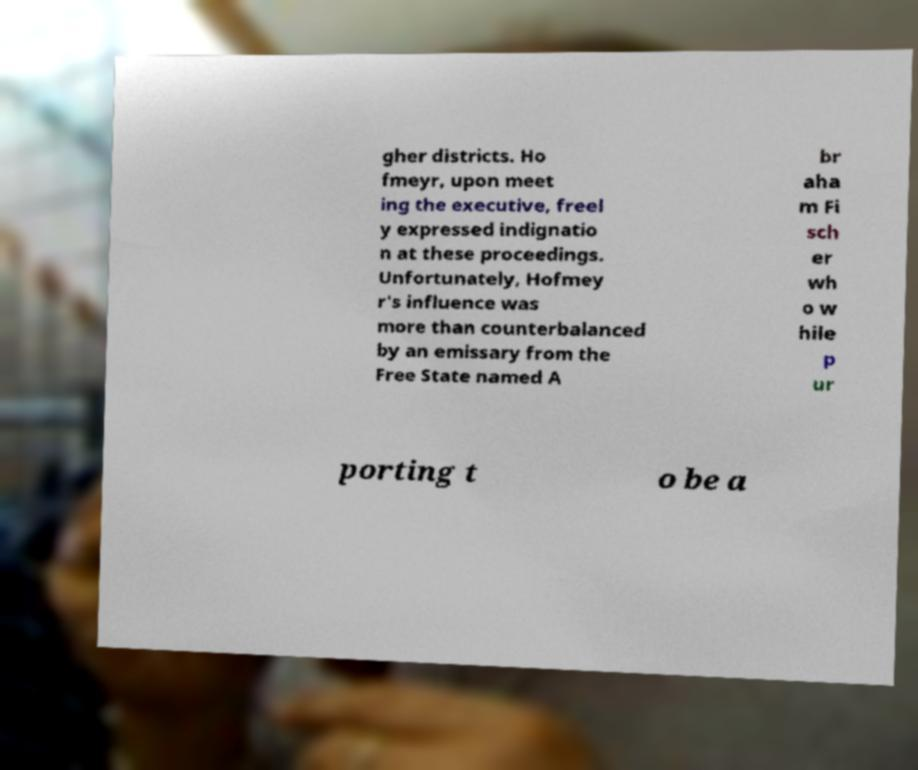Please identify and transcribe the text found in this image. gher districts. Ho fmeyr, upon meet ing the executive, freel y expressed indignatio n at these proceedings. Unfortunately, Hofmey r's influence was more than counterbalanced by an emissary from the Free State named A br aha m Fi sch er wh o w hile p ur porting t o be a 